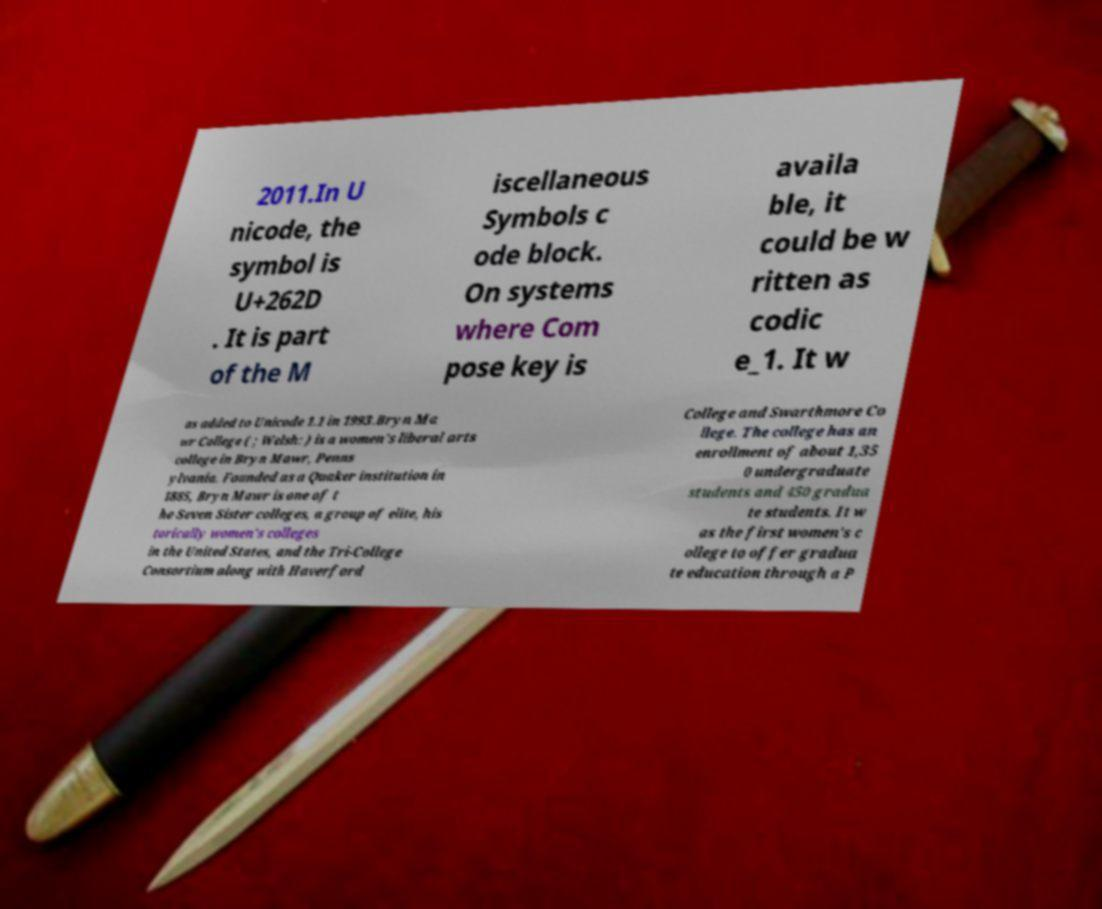I need the written content from this picture converted into text. Can you do that? 2011.In U nicode, the symbol is U+262D . It is part of the M iscellaneous Symbols c ode block. On systems where Com pose key is availa ble, it could be w ritten as codic e_1. It w as added to Unicode 1.1 in 1993.Bryn Ma wr College ( ; Welsh: ) is a women's liberal arts college in Bryn Mawr, Penns ylvania. Founded as a Quaker institution in 1885, Bryn Mawr is one of t he Seven Sister colleges, a group of elite, his torically women's colleges in the United States, and the Tri-College Consortium along with Haverford College and Swarthmore Co llege. The college has an enrollment of about 1,35 0 undergraduate students and 450 gradua te students. It w as the first women's c ollege to offer gradua te education through a P 